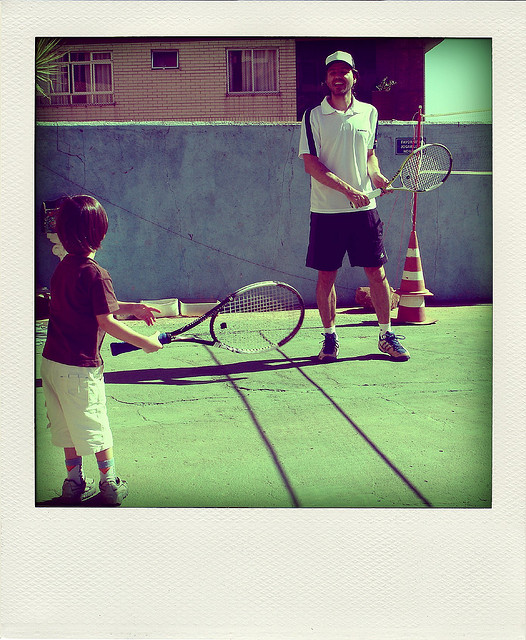<image>Which player has the ball? I don't know which player has the ball. It can be neither of them or could be the boy, man, or adult. Which player has the ball? It is ambiguous which player has the ball. 